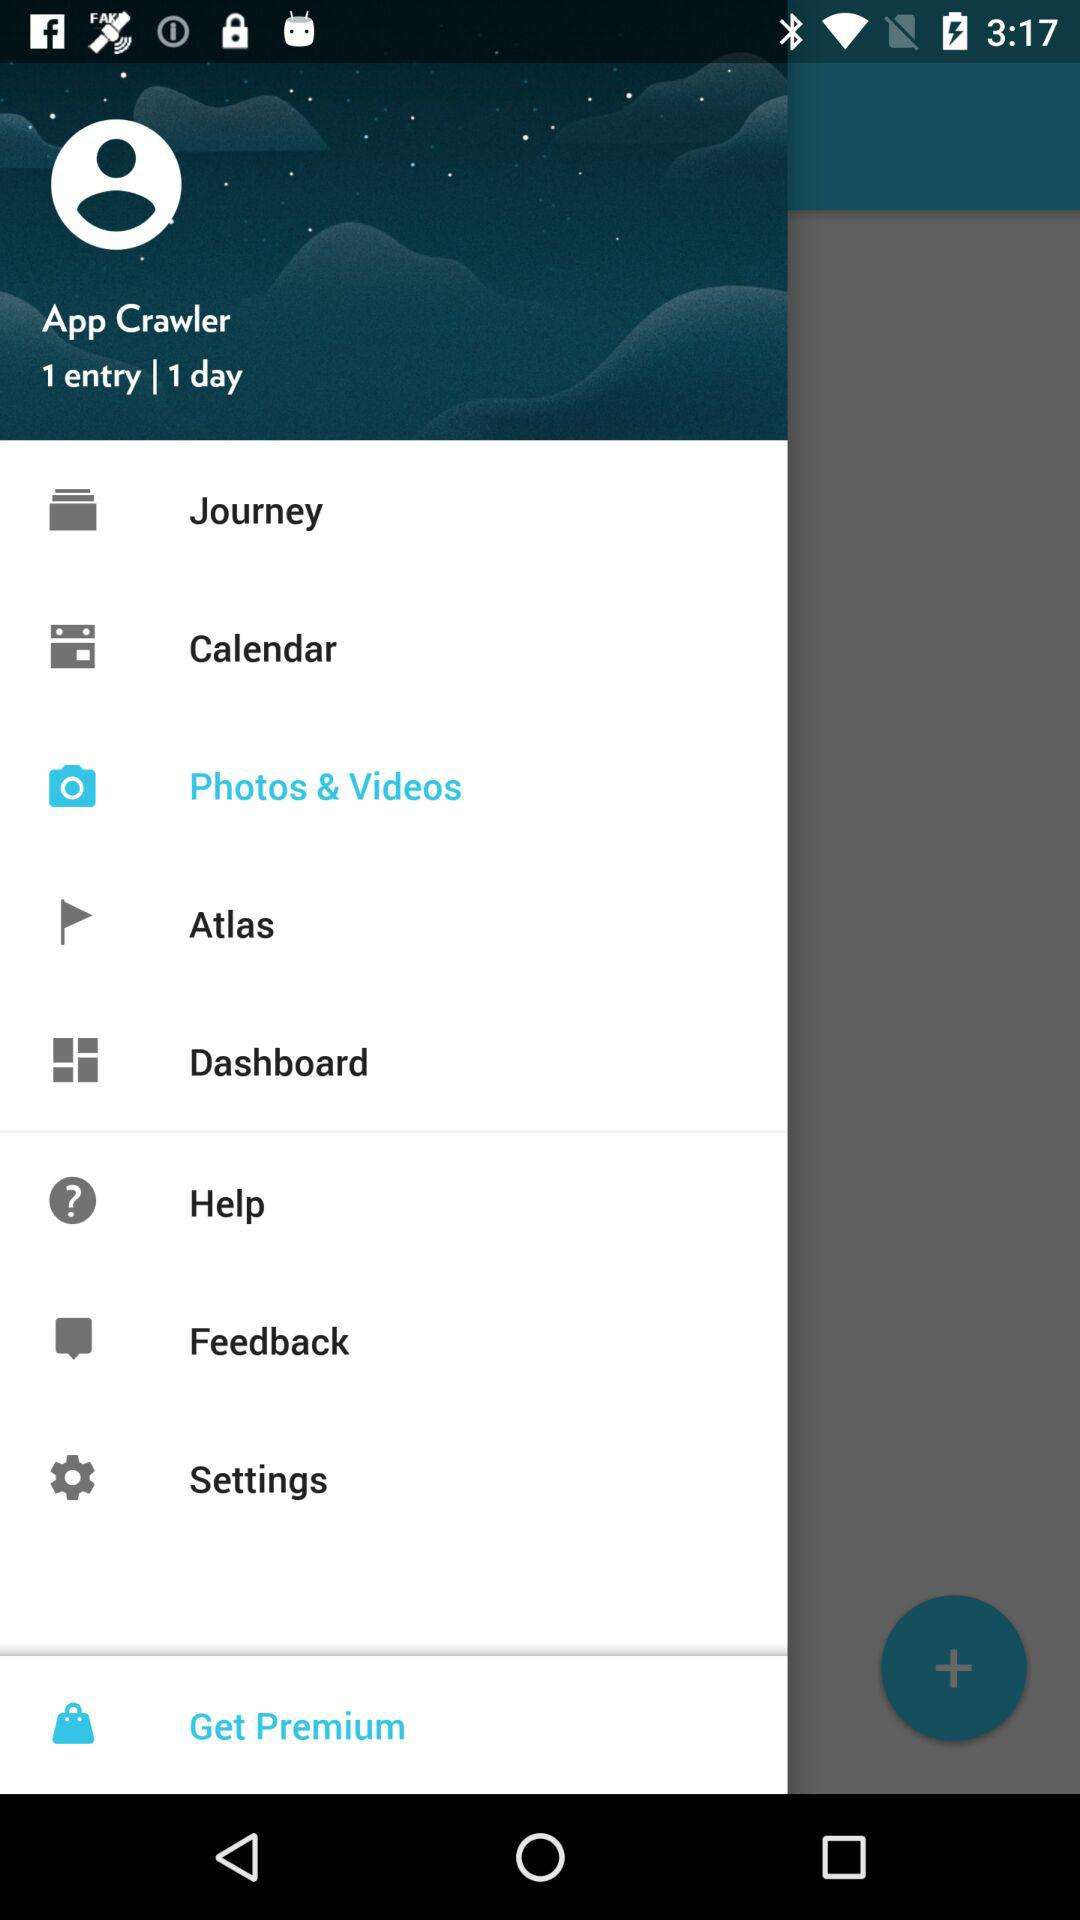What is the number of entries? There is only one entry. 